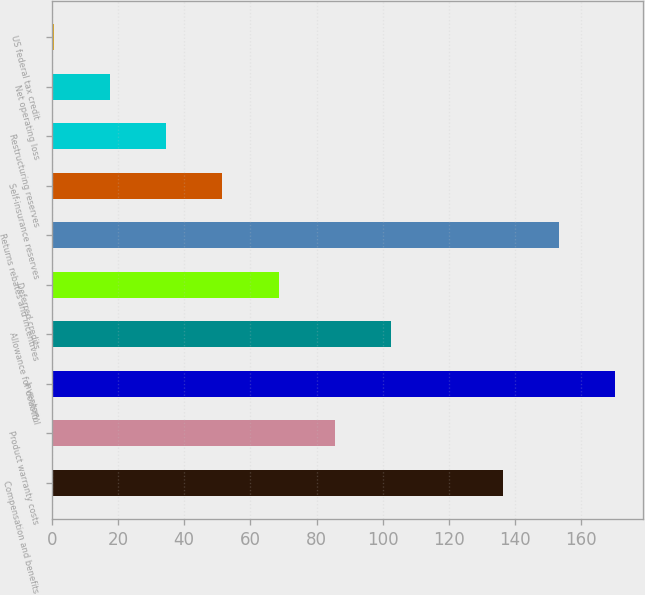Convert chart. <chart><loc_0><loc_0><loc_500><loc_500><bar_chart><fcel>Compensation and benefits<fcel>Product warranty costs<fcel>Inventory<fcel>Allowance for doubtful<fcel>Deferred credits<fcel>Returns rebates and incentives<fcel>Self-insurance reserves<fcel>Restructuring reserves<fcel>Net operating loss<fcel>US federal tax credit<nl><fcel>136.3<fcel>85.45<fcel>170.2<fcel>102.4<fcel>68.5<fcel>153.25<fcel>51.55<fcel>34.6<fcel>17.65<fcel>0.7<nl></chart> 